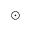Convert formula to latex. <formula><loc_0><loc_0><loc_500><loc_500>{ \odot }</formula> 